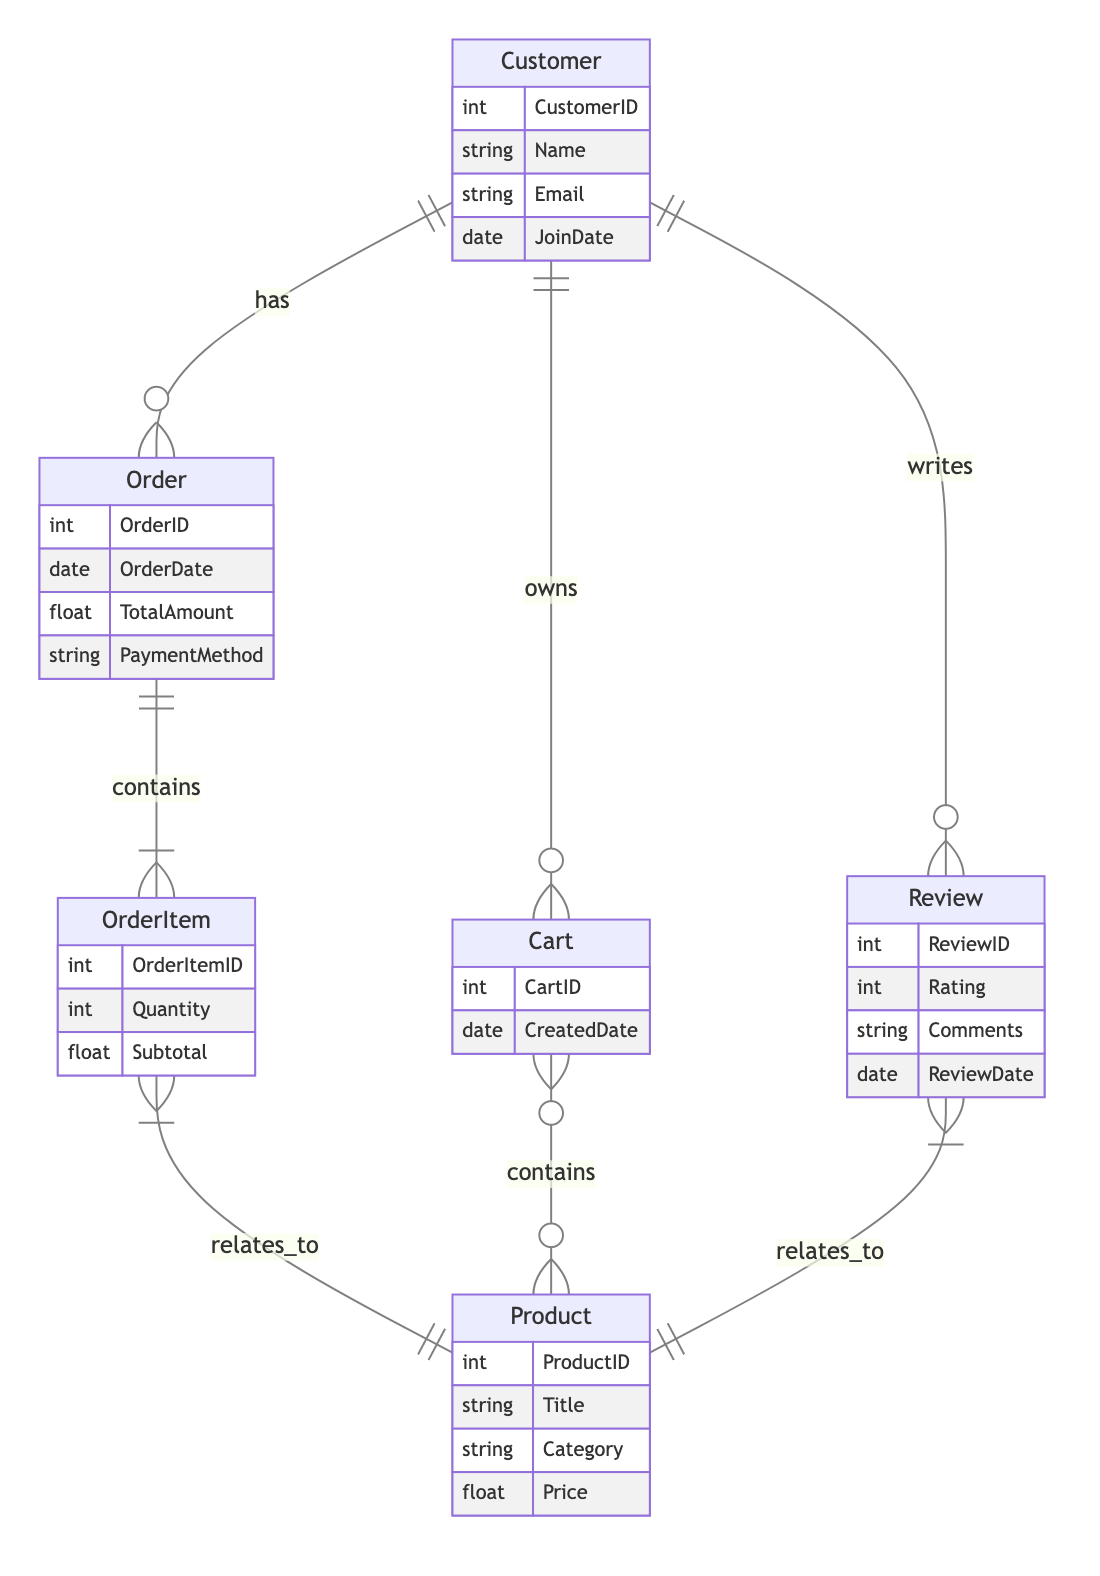What entity is related to the OrderItem? The OrderItem is related to the Product entity, as indicated by the relationship "relates_to" connecting them in the diagram.
Answer: Product How many attributes does the Customer entity have? The Customer entity has four attributes: CustomerID, Name, Email, and JoinDate. This can be counted directly from the attributes list under the Customer entity in the diagram.
Answer: Four What is the primary relationship between Customer and Cart? The primary relationship is that a Customer "owns" a Cart, which means each Customer can have one or more Carts associated with their profile as depicted in the diagram.
Answer: owns How many entities are shown in this diagram? There are six entities: Customer, Product, Order, OrderItem, Cart, and Review. Counting each listed entity provides the total number of entities in the diagram.
Answer: Six Which entity contains the relationship of "contains"? The Order entity contains the "contains" relationship with the OrderItem entity, indicating that an Order can have multiple OrderItems associated with it.
Answer: Order Which attribute belongs to the Product entity? The Price is one of the attributes of the Product entity, as specified in the attributes section under the Product entity in the diagram.
Answer: Price What does the Review entity consist of concerning its relationship with Customer? The Review entity consists of reviews that are "written_by" the Customer, signifying that Customers can leave reviews on Products.
Answer: written_by How many relationships are shown for the Product entity? The Product entity has two relationships: it is related to OrderItem and Review, summing up to a total of two relationships depicted in the diagram.
Answer: Two What relationship defines how Cart interacts with Product? The Cart has a "contains" relationship with Product, meaning that a Cart can contain multiple Products.
Answer: contains 